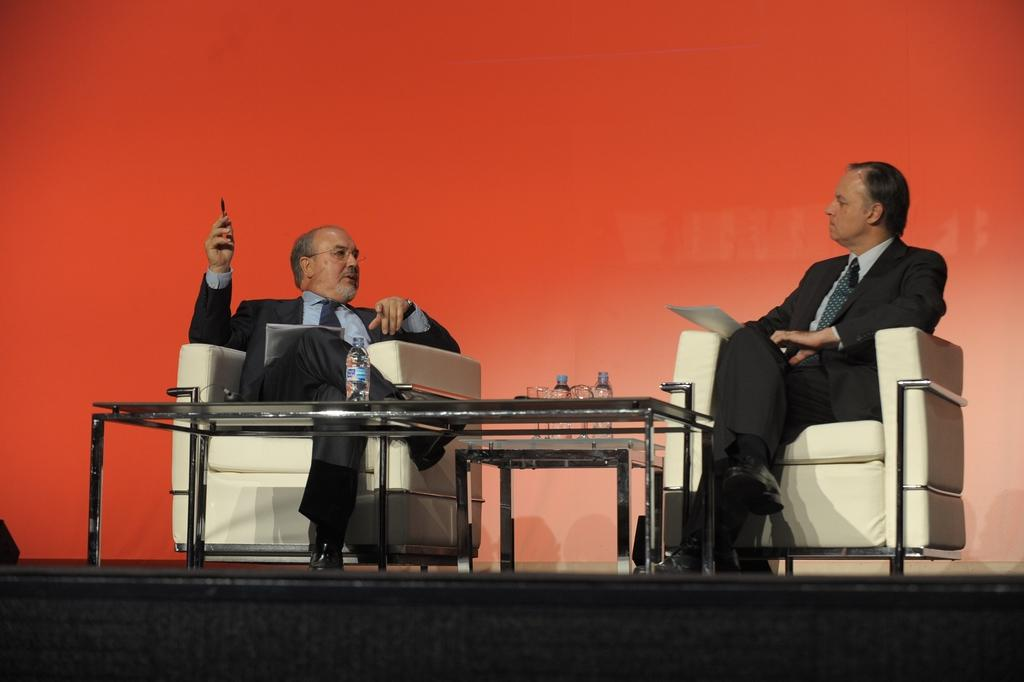How many people are in the image? There are two persons in the image. What are the persons doing in the image? The persons are sitting on a couch. Can you describe any objects in the image besides the couch? Yes, there is a water bottle on a table in the image. What type of health advice can be seen on the badge worn by one of the persons in the image? There is no badge present in the image, and therefore no health advice can be seen. 